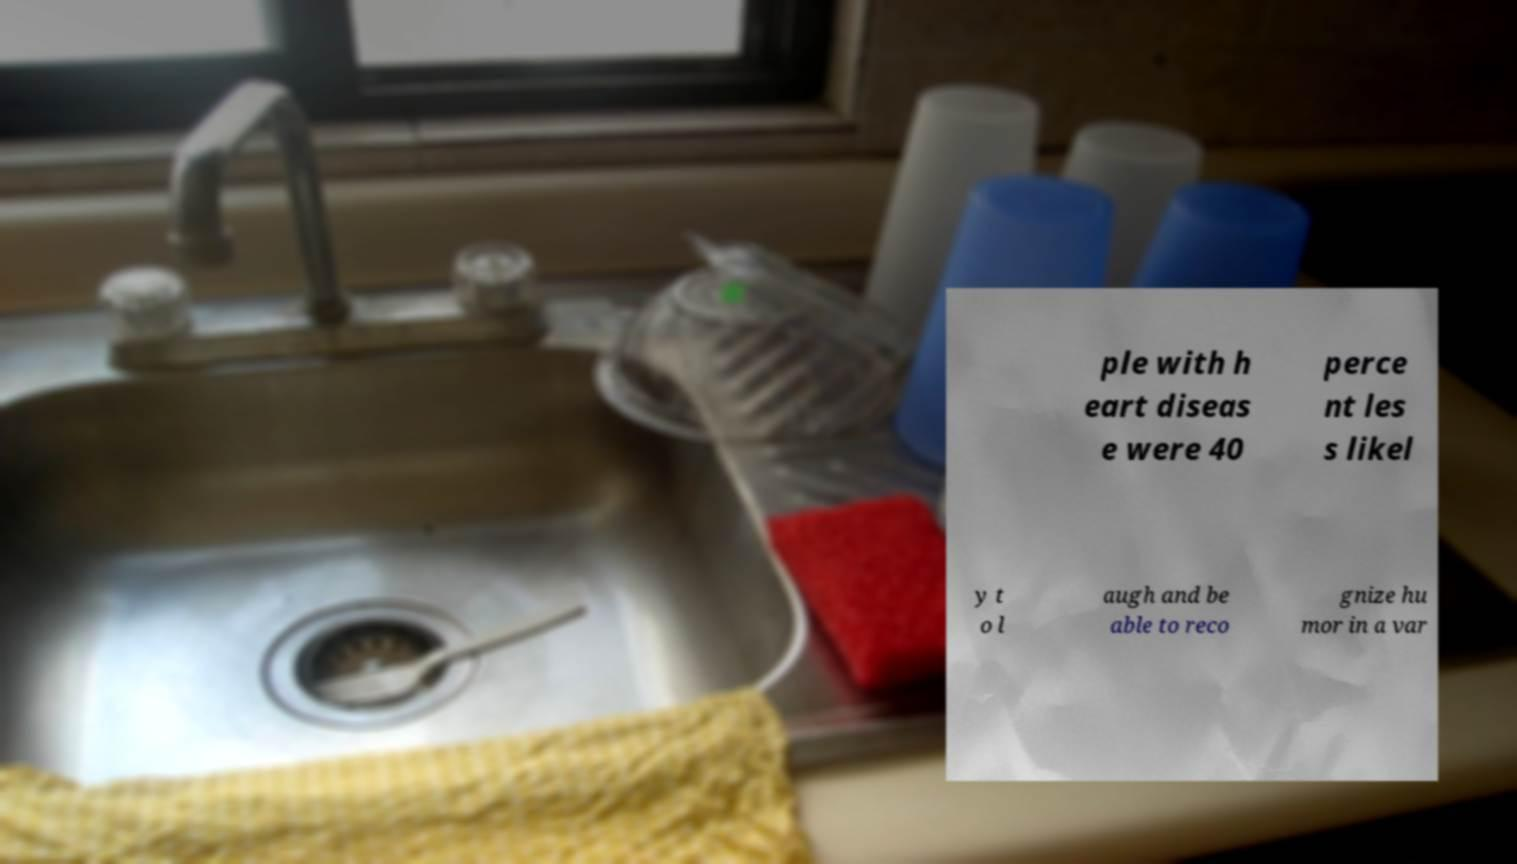Please identify and transcribe the text found in this image. ple with h eart diseas e were 40 perce nt les s likel y t o l augh and be able to reco gnize hu mor in a var 